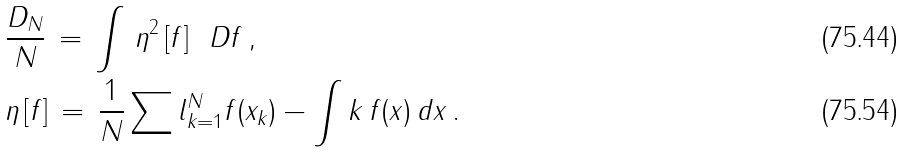Convert formula to latex. <formula><loc_0><loc_0><loc_500><loc_500>& \frac { D _ { N } } { N } \, = \, \int \, \eta ^ { 2 } \left [ f \right ] \, \ D f \, , \\ & \eta \, [ f ] \, = \, \frac { 1 } { N } \sum l _ { k = 1 } ^ { N } f ( x _ { k } ) - \int k \, f ( x ) \, d x \, .</formula> 